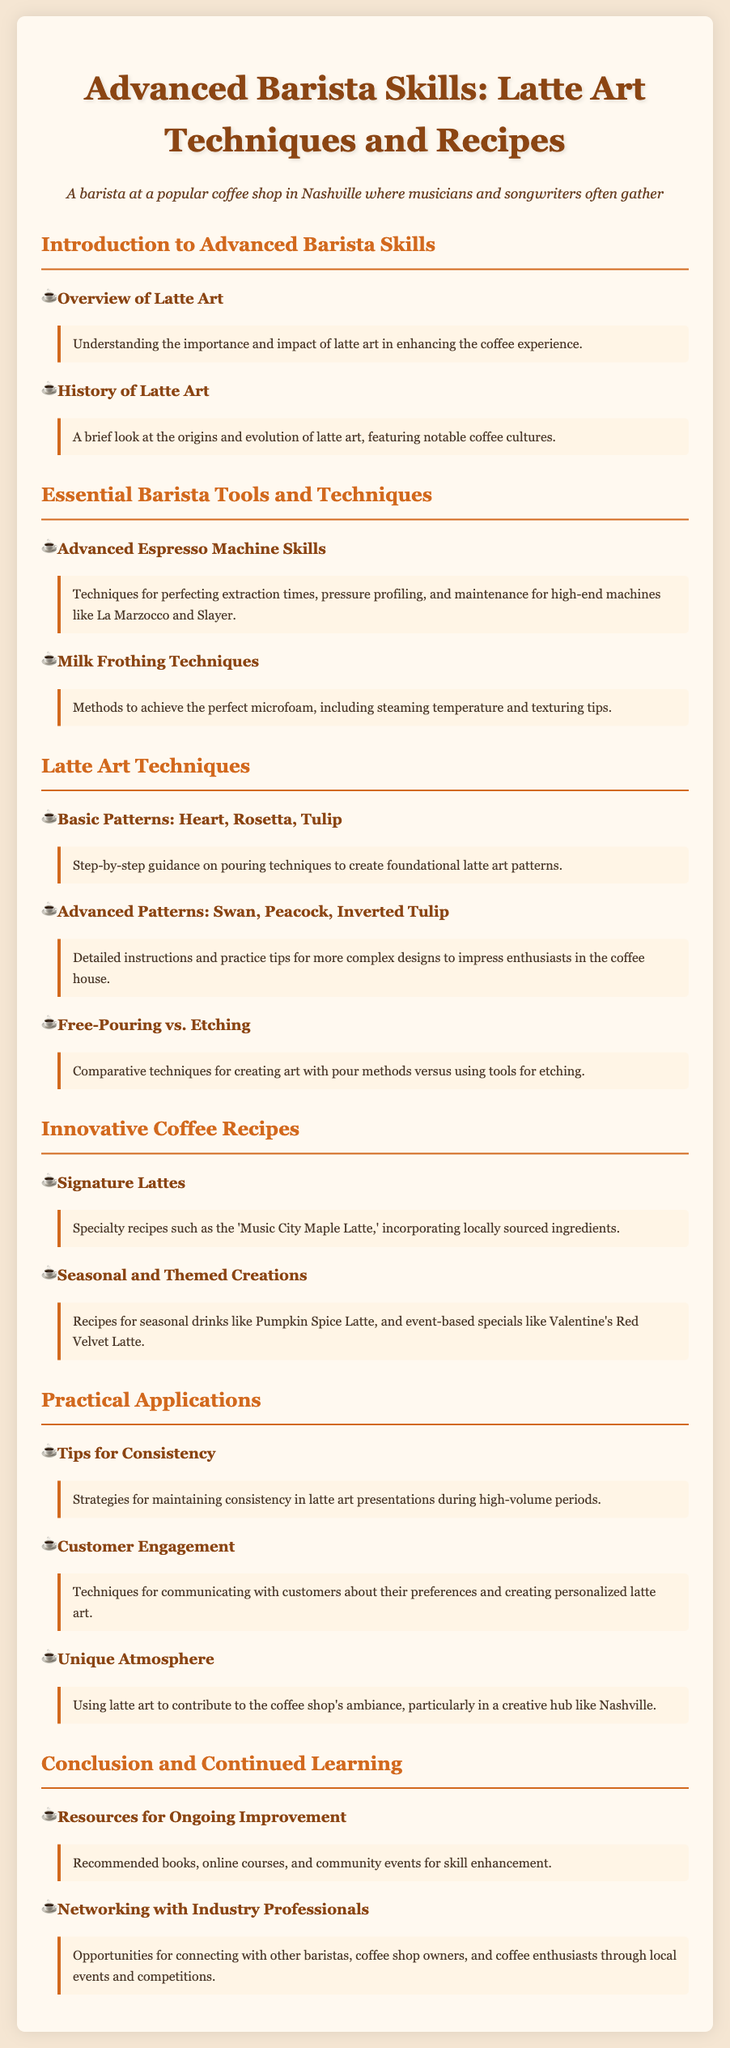what is the title of the syllabus? The title of the syllabus is clearly stated at the beginning of the document.
Answer: Advanced Barista Skills: Latte Art Techniques and Recipes how many essential barista tools and techniques are listed? The number of sections under Essential Barista Tools and Techniques can be counted in the document.
Answer: 2 what are the names of two basic latte art patterns mentioned? The document lists specific patterns under the Latte Art Techniques section.
Answer: Heart, Rosetta what is the name of the signature latte recipe mentioned? The signature latte recipe is highlighted in the Innovative Coffee Recipes section.
Answer: Music City Maple Latte which type of milk frothing technique is focused on for achieving microfoam? The specific focus on the type of milk frothing technique can be found in the section on Milk Frothing Techniques.
Answer: Texturing tips how does the syllabus suggest maintaining consistency during high-volume periods? The section under Practical Applications addresses tips for consistency.
Answer: Strategies what opportunities for professional networking are mentioned? The document highlights specific areas for networking under the Conclusion and Continued Learning section.
Answer: Local events and competitions what cultural aspect is briefly discussed in the history of latte art? The History of Latte Art section provides insights into notable coffee cultures.
Answer: Notable coffee cultures what innovative seasonal drink is cited in the syllabus? An example of a seasonal drink can be found in the Innovative Coffee Recipes section.
Answer: Pumpkin Spice Latte 